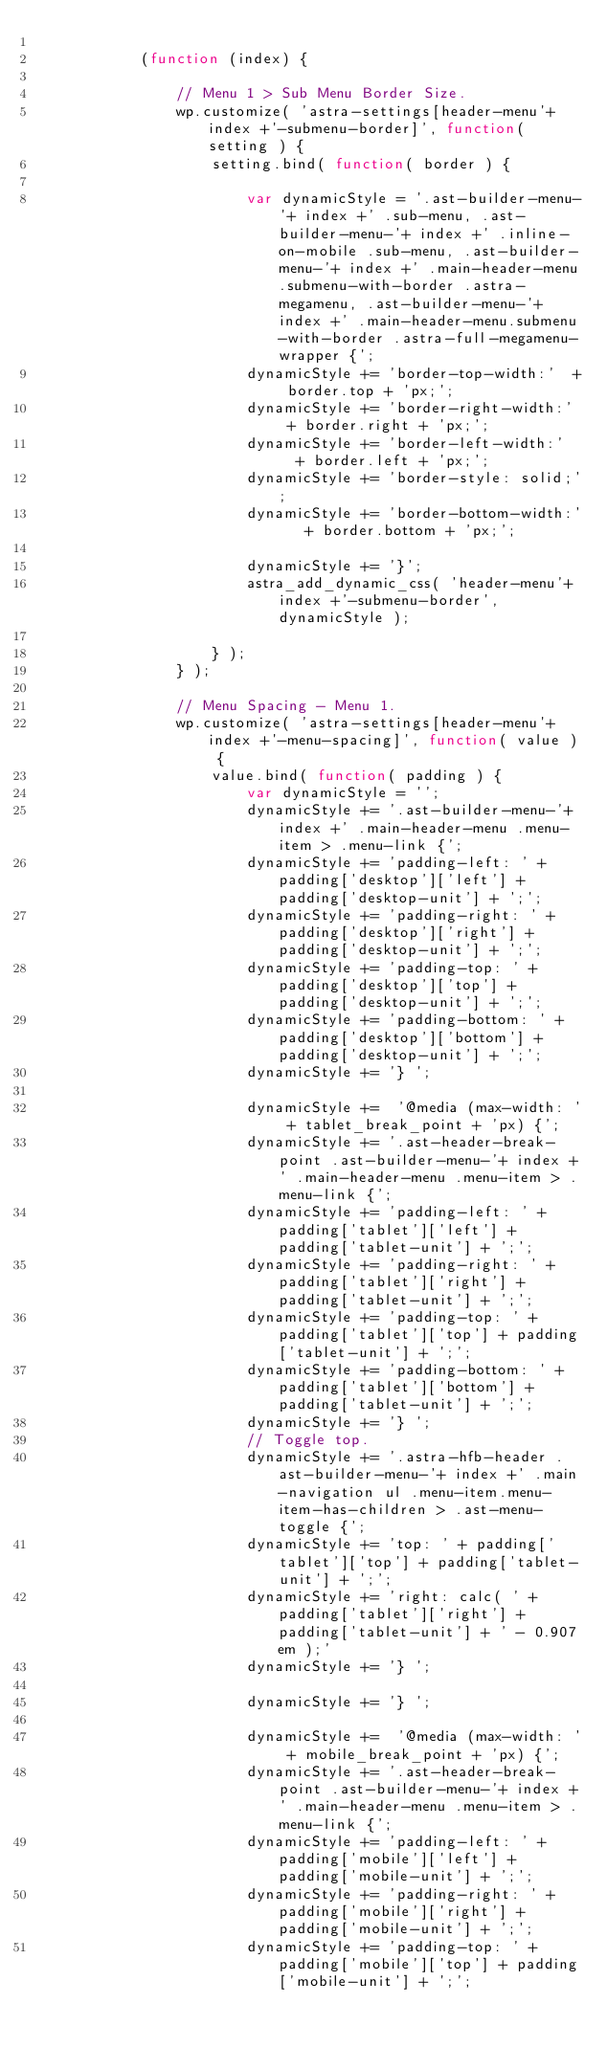Convert code to text. <code><loc_0><loc_0><loc_500><loc_500><_JavaScript_>
			(function (index) {

				// Menu 1 > Sub Menu Border Size.
				wp.customize( 'astra-settings[header-menu'+ index +'-submenu-border]', function( setting ) {
					setting.bind( function( border ) {

						var dynamicStyle = '.ast-builder-menu-'+ index +' .sub-menu, .ast-builder-menu-'+ index +' .inline-on-mobile .sub-menu, .ast-builder-menu-'+ index +' .main-header-menu.submenu-with-border .astra-megamenu, .ast-builder-menu-'+ index +' .main-header-menu.submenu-with-border .astra-full-megamenu-wrapper {';
						dynamicStyle += 'border-top-width:'  + border.top + 'px;';
						dynamicStyle += 'border-right-width:'  + border.right + 'px;';
						dynamicStyle += 'border-left-width:'   + border.left + 'px;';
						dynamicStyle += 'border-style: solid;';
						dynamicStyle += 'border-bottom-width:'   + border.bottom + 'px;';

						dynamicStyle += '}';
						astra_add_dynamic_css( 'header-menu'+ index +'-submenu-border', dynamicStyle );

					} );
				} );

				// Menu Spacing - Menu 1.
				wp.customize( 'astra-settings[header-menu'+ index +'-menu-spacing]', function( value ) {
					value.bind( function( padding ) {
						var dynamicStyle = '';
						dynamicStyle += '.ast-builder-menu-'+ index +' .main-header-menu .menu-item > .menu-link {';
						dynamicStyle += 'padding-left: ' + padding['desktop']['left'] + padding['desktop-unit'] + ';';
						dynamicStyle += 'padding-right: ' + padding['desktop']['right'] + padding['desktop-unit'] + ';';
						dynamicStyle += 'padding-top: ' + padding['desktop']['top'] + padding['desktop-unit'] + ';';
						dynamicStyle += 'padding-bottom: ' + padding['desktop']['bottom'] + padding['desktop-unit'] + ';';
						dynamicStyle += '} ';

						dynamicStyle +=  '@media (max-width: ' + tablet_break_point + 'px) {';
						dynamicStyle += '.ast-header-break-point .ast-builder-menu-'+ index +' .main-header-menu .menu-item > .menu-link {';
						dynamicStyle += 'padding-left: ' + padding['tablet']['left'] + padding['tablet-unit'] + ';';
						dynamicStyle += 'padding-right: ' + padding['tablet']['right'] + padding['tablet-unit'] + ';';
						dynamicStyle += 'padding-top: ' + padding['tablet']['top'] + padding['tablet-unit'] + ';';
						dynamicStyle += 'padding-bottom: ' + padding['tablet']['bottom'] + padding['tablet-unit'] + ';';
						dynamicStyle += '} ';
						// Toggle top.
						dynamicStyle += '.astra-hfb-header .ast-builder-menu-'+ index +' .main-navigation ul .menu-item.menu-item-has-children > .ast-menu-toggle {';
						dynamicStyle += 'top: ' + padding['tablet']['top'] + padding['tablet-unit'] + ';';
						dynamicStyle += 'right: calc( ' + padding['tablet']['right'] + padding['tablet-unit'] + ' - 0.907em );'
						dynamicStyle += '} ';

						dynamicStyle += '} ';

						dynamicStyle +=  '@media (max-width: ' + mobile_break_point + 'px) {';
						dynamicStyle += '.ast-header-break-point .ast-builder-menu-'+ index +' .main-header-menu .menu-item > .menu-link {';
						dynamicStyle += 'padding-left: ' + padding['mobile']['left'] + padding['mobile-unit'] + ';';
						dynamicStyle += 'padding-right: ' + padding['mobile']['right'] + padding['mobile-unit'] + ';';
						dynamicStyle += 'padding-top: ' + padding['mobile']['top'] + padding['mobile-unit'] + ';';</code> 